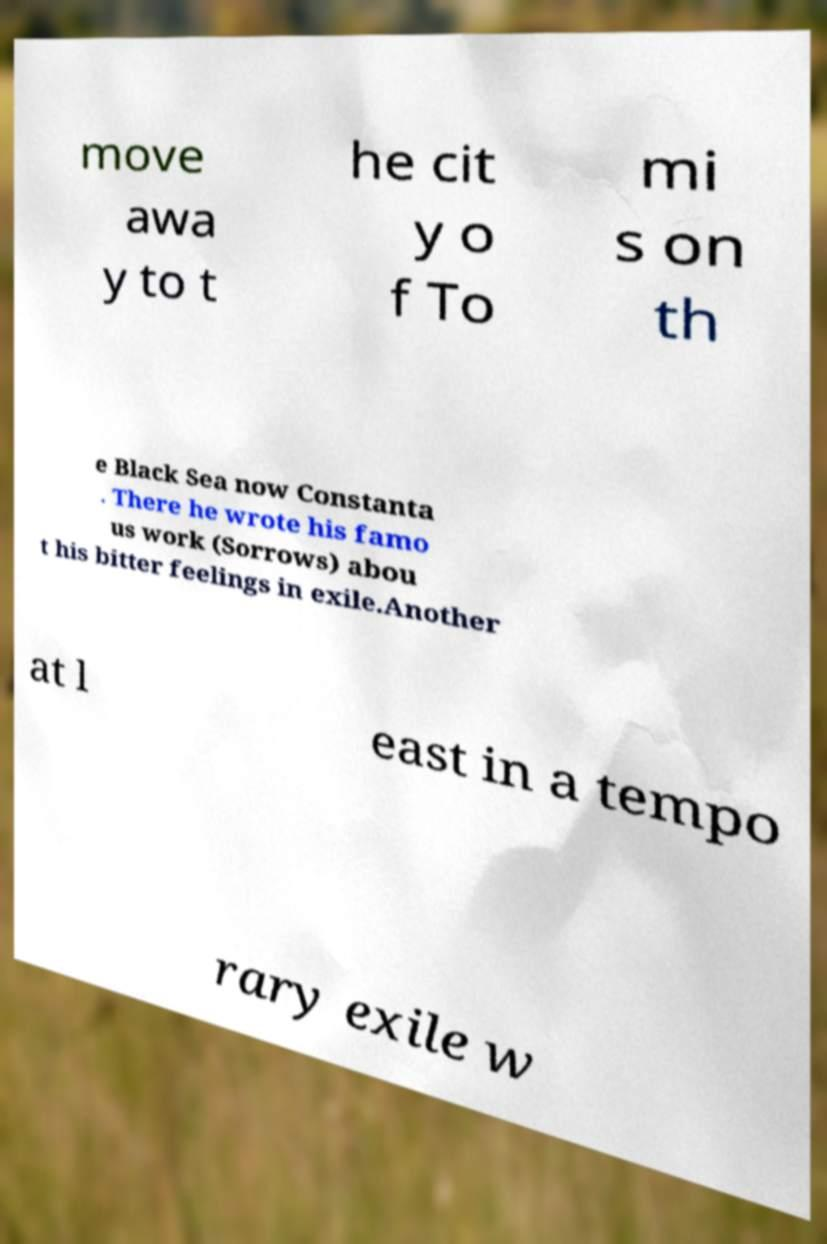Can you accurately transcribe the text from the provided image for me? move awa y to t he cit y o f To mi s on th e Black Sea now Constanta . There he wrote his famo us work (Sorrows) abou t his bitter feelings in exile.Another at l east in a tempo rary exile w 